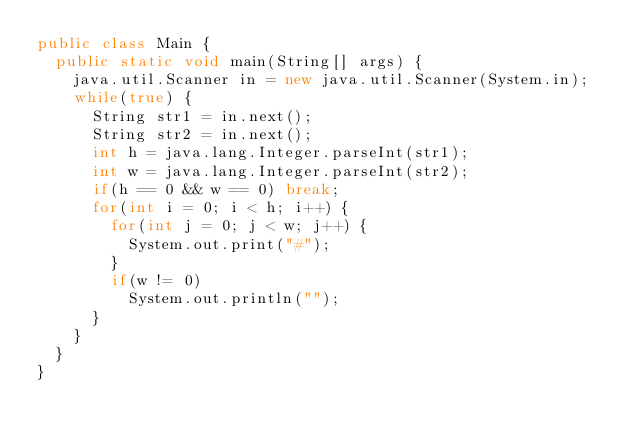Convert code to text. <code><loc_0><loc_0><loc_500><loc_500><_Java_>public class Main {
	public static void main(String[] args) {
		java.util.Scanner in = new java.util.Scanner(System.in);
		while(true) {
			String str1 = in.next();
			String str2 = in.next();
			int h = java.lang.Integer.parseInt(str1);
			int w = java.lang.Integer.parseInt(str2);
			if(h == 0 && w == 0) break;
			for(int i = 0; i < h; i++) {
				for(int j = 0; j < w; j++) {
					System.out.print("#");
				}
				if(w != 0)
					System.out.println("");
			}
		}
	}
}</code> 